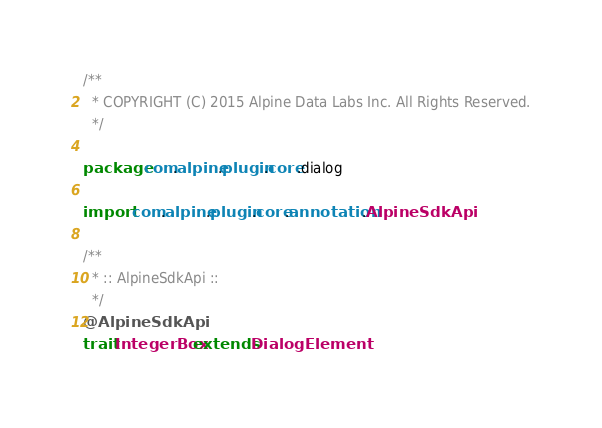Convert code to text. <code><loc_0><loc_0><loc_500><loc_500><_Scala_>/**
  * COPYRIGHT (C) 2015 Alpine Data Labs Inc. All Rights Reserved.
  */

package com.alpine.plugin.core.dialog

import com.alpine.plugin.core.annotation.AlpineSdkApi

/**
  * :: AlpineSdkApi ::
  */
@AlpineSdkApi
trait IntegerBox extends DialogElement</code> 